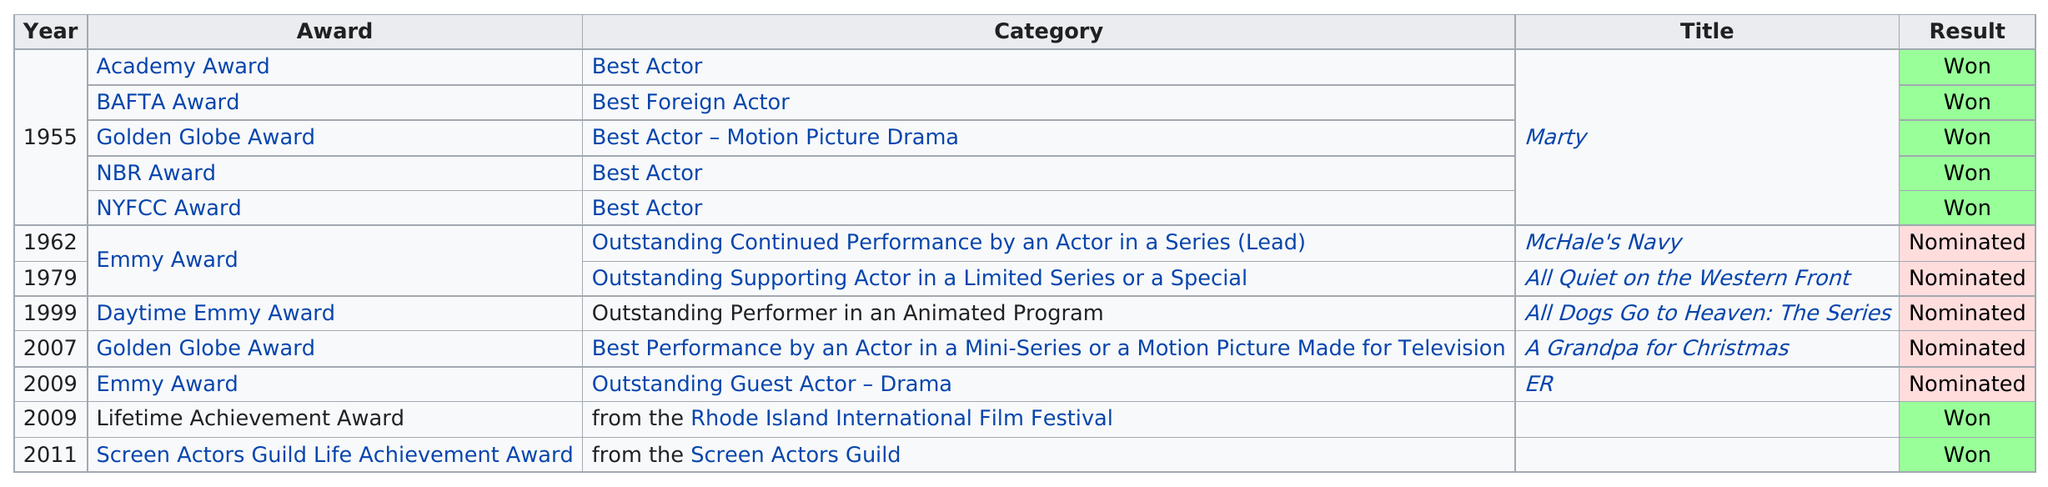Specify some key components in this picture. The actor was nominated for a movie titled "McHale's Navy" after the movie "Marty. He won a total of 7 awards. The actor was awarded both an nbr award and a nyfcc award for his outstanding performance in the film Marty. Marty won a total of 5 awards. The actor was nominated for a Daytime Emmy Award for their performance in the television show "All Dogs Go to Heaven: The Series," which was the only program for which they received this nomination. 